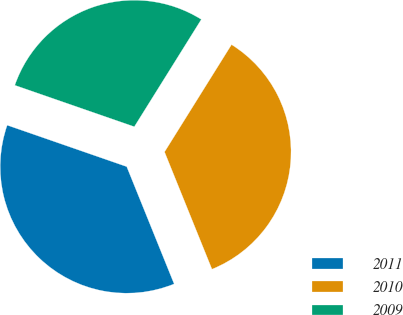<chart> <loc_0><loc_0><loc_500><loc_500><pie_chart><fcel>2011<fcel>2010<fcel>2009<nl><fcel>36.43%<fcel>35.0%<fcel>28.57%<nl></chart> 